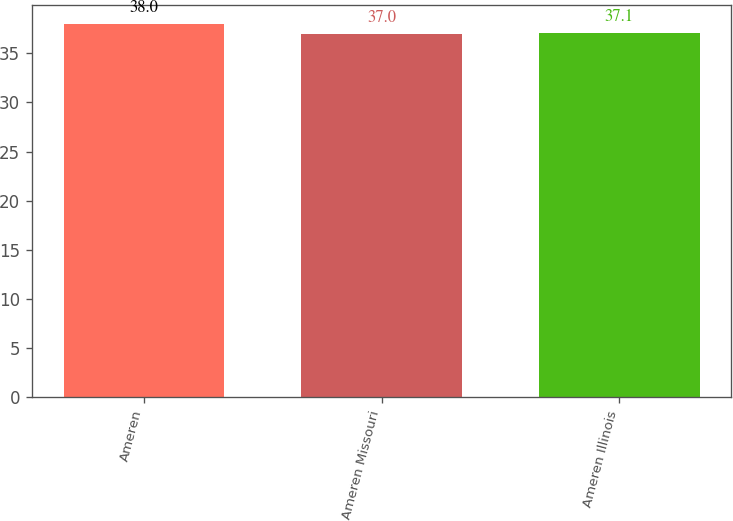Convert chart. <chart><loc_0><loc_0><loc_500><loc_500><bar_chart><fcel>Ameren<fcel>Ameren Missouri<fcel>Ameren Illinois<nl><fcel>38<fcel>37<fcel>37.1<nl></chart> 